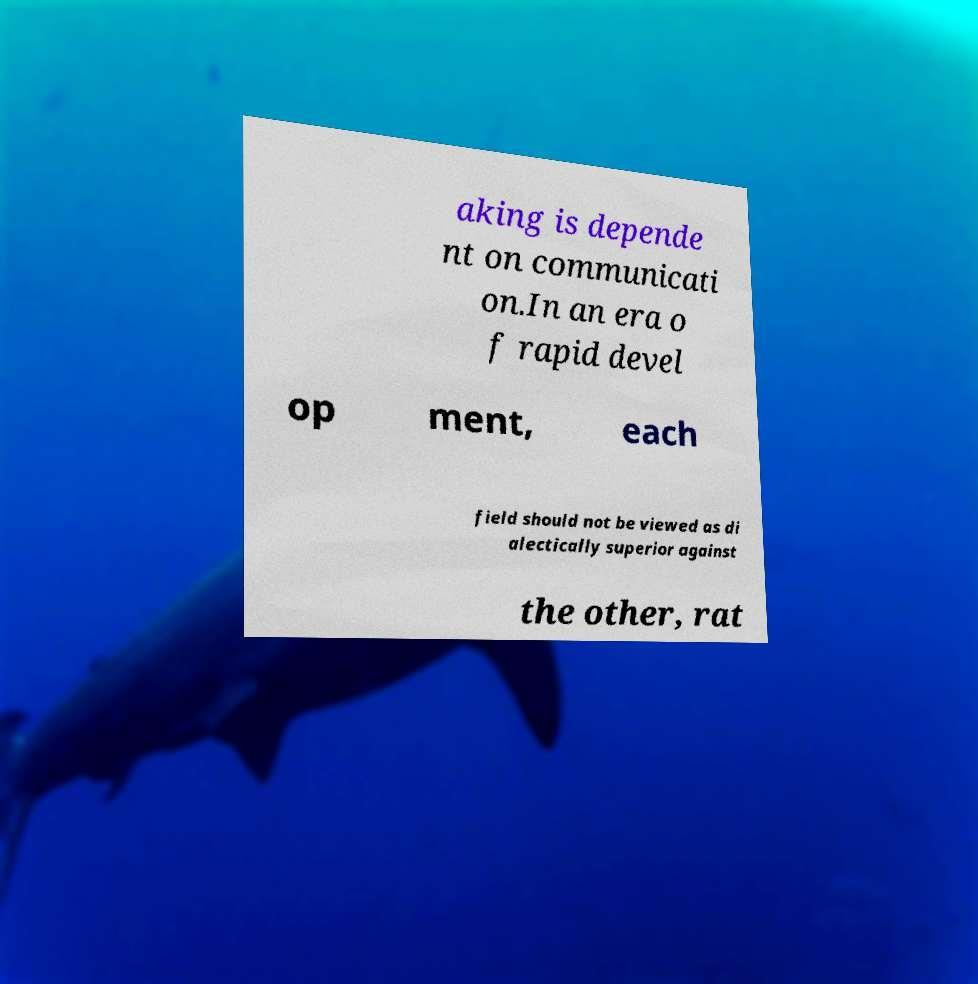I need the written content from this picture converted into text. Can you do that? aking is depende nt on communicati on.In an era o f rapid devel op ment, each field should not be viewed as di alectically superior against the other, rat 